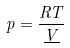Convert formula to latex. <formula><loc_0><loc_0><loc_500><loc_500>p = \frac { R T } { \underline { V } }</formula> 